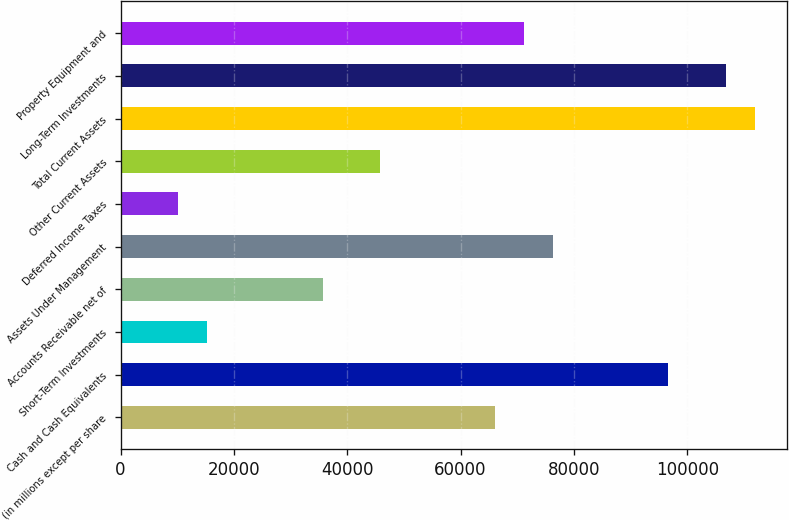Convert chart to OTSL. <chart><loc_0><loc_0><loc_500><loc_500><bar_chart><fcel>(in millions except per share<fcel>Cash and Cash Equivalents<fcel>Short-Term Investments<fcel>Accounts Receivable net of<fcel>Assets Under Management<fcel>Deferred Income Taxes<fcel>Other Current Assets<fcel>Total Current Assets<fcel>Long-Term Investments<fcel>Property Equipment and<nl><fcel>66164.8<fcel>96696.4<fcel>15278.8<fcel>35633.2<fcel>76342<fcel>10190.2<fcel>45810.4<fcel>111962<fcel>106874<fcel>71253.4<nl></chart> 